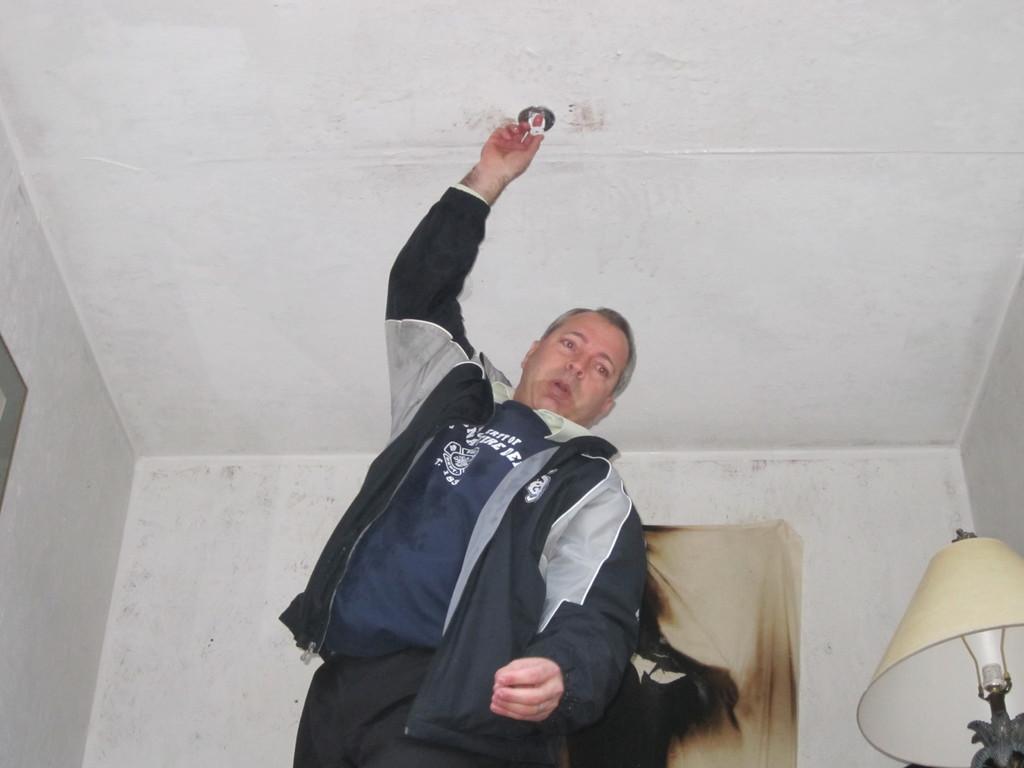Could you give a brief overview of what you see in this image? In this image we can see a person holding an object. There is a lamp at the right side of the image. There is an object at the left of the image. We can see the walls in the image. There is an object on the wall. 